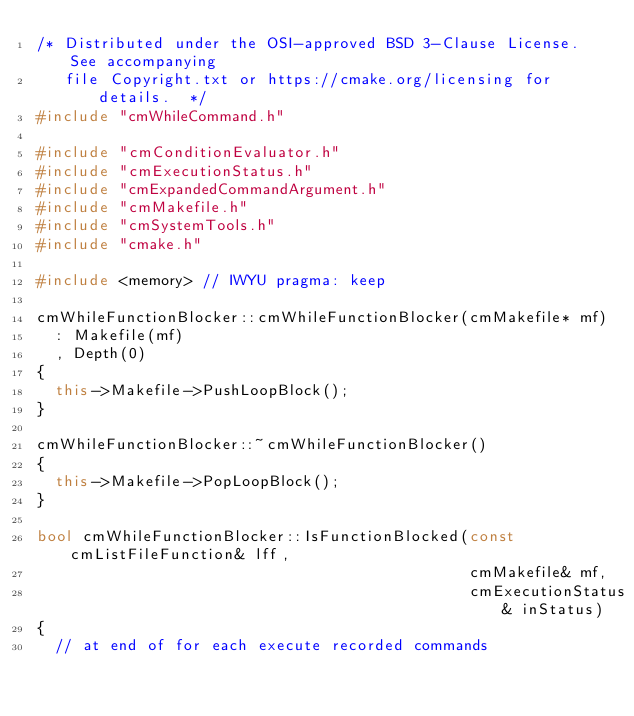Convert code to text. <code><loc_0><loc_0><loc_500><loc_500><_C++_>/* Distributed under the OSI-approved BSD 3-Clause License.  See accompanying
   file Copyright.txt or https://cmake.org/licensing for details.  */
#include "cmWhileCommand.h"

#include "cmConditionEvaluator.h"
#include "cmExecutionStatus.h"
#include "cmExpandedCommandArgument.h"
#include "cmMakefile.h"
#include "cmSystemTools.h"
#include "cmake.h"

#include <memory> // IWYU pragma: keep

cmWhileFunctionBlocker::cmWhileFunctionBlocker(cmMakefile* mf)
  : Makefile(mf)
  , Depth(0)
{
  this->Makefile->PushLoopBlock();
}

cmWhileFunctionBlocker::~cmWhileFunctionBlocker()
{
  this->Makefile->PopLoopBlock();
}

bool cmWhileFunctionBlocker::IsFunctionBlocked(const cmListFileFunction& lff,
                                               cmMakefile& mf,
                                               cmExecutionStatus& inStatus)
{
  // at end of for each execute recorded commands</code> 